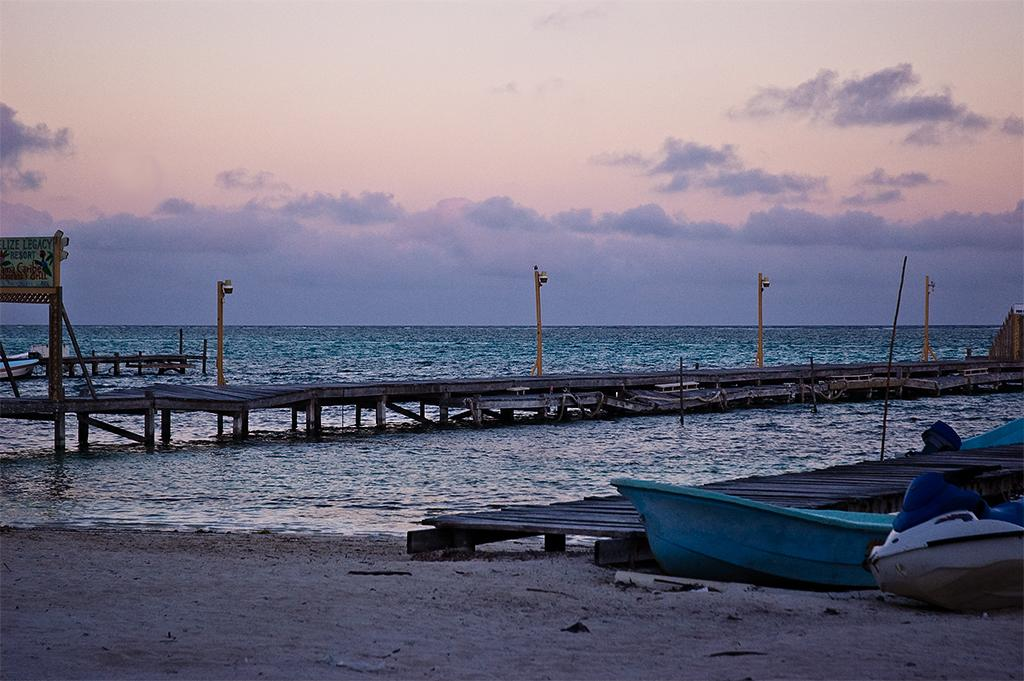What type of structures are present in the image? There are board bridges in the image. What else can be seen in the image besides the board bridges? There are poles, boats, boards, clouds in the sky, water, and sand visible in the image. What might the boats be used for in the image? The boats might be used for transportation or recreation in the water. What is the texture of the ground visible in the image? The ground visible in the image is sand. What type of mitten is being used to hold the wire in the image? There is no mitten or wire present in the image. 